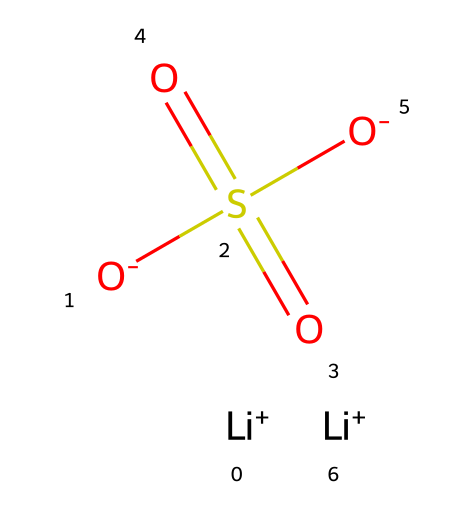What is the overall charge of this compound? In the given SMILES, there are two lithium cations ([Li+]) and two negative charges from the sulfate groups ([O-]S(=O)(=O)[O-]). The overall charge can be calculated: two +1 charges from lithium and minus two from sulfate, resulting in a net charge of zero.
Answer: zero How many sulfur atoms are present in this structure? By analyzing the SMILES representation, there is one sulfur atom denoted by the 'S' in the sulfate group.
Answer: one What type of bond connects the lithium ions to the sulfate group? The lithium ions are cations and are ionically bonded to the negatively charged sulfate anions. Ionic bonds are formed between cations and anions due to electrostatic attraction.
Answer: ionic How many oxygen atoms are in the compound? There are four oxygen atoms: two from the sulfate group and one counted with the double bond to sulfur (S=O) and two single-bonded oxygens.
Answer: four What is the functional group present in this molecule? The structure shows a sulfate functional group, characterized by the sulfur atom bonded to four oxygen atoms (one double bond and three single). This indicates that it’s a sulfonate.
Answer: sulfate Which element in this structure can store and release energy during battery operation? Lithium plays a critical role in the battery operation as it is involved in the intercalation/deintercalation process, which is key for energy storage and release in lithium-ion batteries.
Answer: lithium 